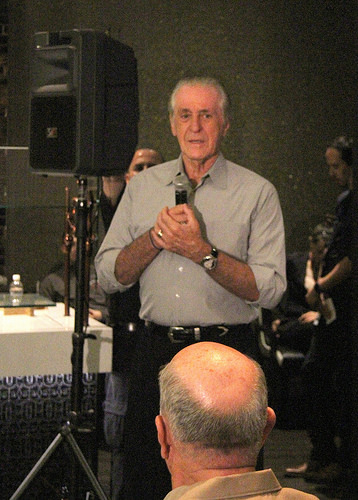<image>
Is there a belt behind the microphone? No. The belt is not behind the microphone. From this viewpoint, the belt appears to be positioned elsewhere in the scene. 